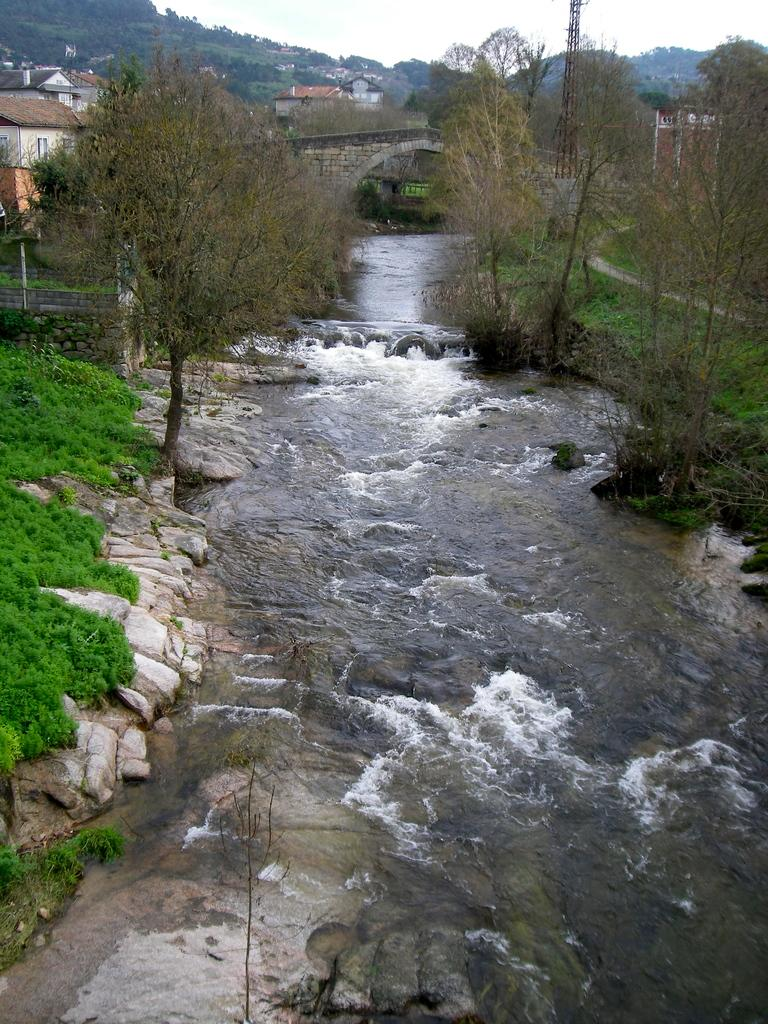What can be seen in the foreground of the image? In the foreground of the image, there is a river on either side, plants, stones, and trees. What structures or objects can be seen in the background of the image? In the background of the image, there is a bridge, clouds in the sky, a tower, and trees. What is visible in the sky in the background of the image? The sky is visible in the background of the image, with clouds present. Can you tell me how many moons are visible in the image? There are no moons visible in the image; only the sunlit sky with clouds is present. What type of border is depicted in the image? There is no border depicted in the image; it features a river, plants, stones, trees, a bridge, clouds, a tower, and trees. 